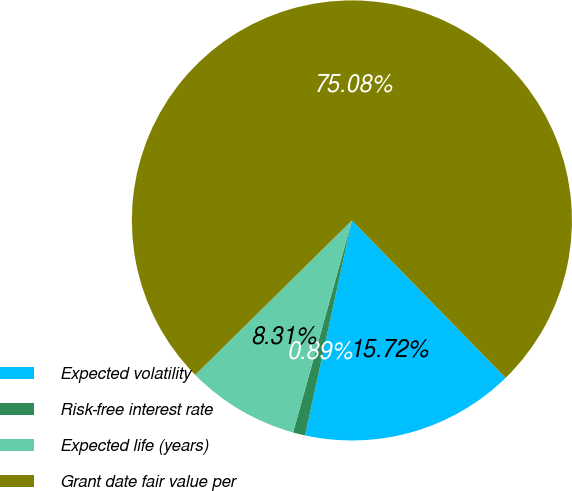<chart> <loc_0><loc_0><loc_500><loc_500><pie_chart><fcel>Expected volatility<fcel>Risk-free interest rate<fcel>Expected life (years)<fcel>Grant date fair value per<nl><fcel>15.72%<fcel>0.89%<fcel>8.31%<fcel>75.08%<nl></chart> 